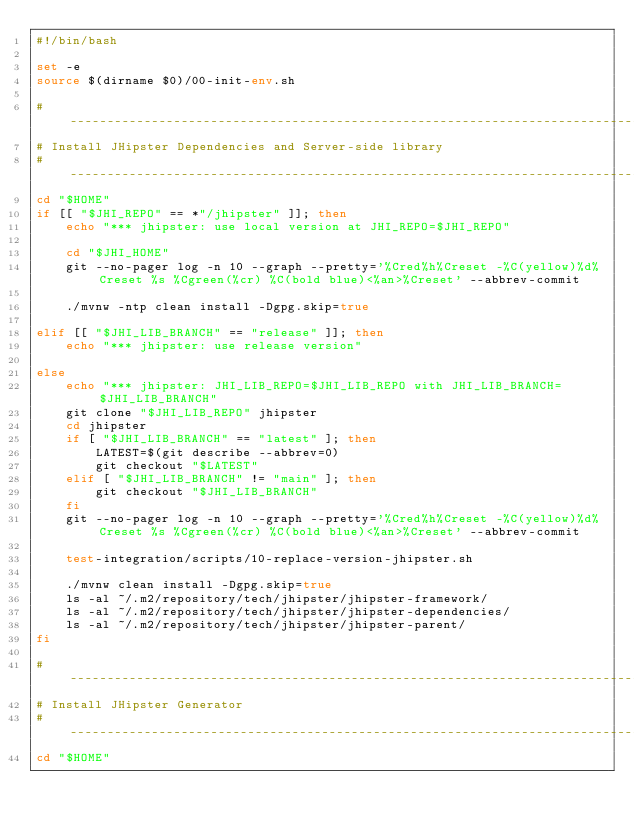Convert code to text. <code><loc_0><loc_0><loc_500><loc_500><_Bash_>#!/bin/bash

set -e
source $(dirname $0)/00-init-env.sh

#-------------------------------------------------------------------------------
# Install JHipster Dependencies and Server-side library
#-------------------------------------------------------------------------------
cd "$HOME"
if [[ "$JHI_REPO" == *"/jhipster" ]]; then
    echo "*** jhipster: use local version at JHI_REPO=$JHI_REPO"

    cd "$JHI_HOME"
    git --no-pager log -n 10 --graph --pretty='%Cred%h%Creset -%C(yellow)%d%Creset %s %Cgreen(%cr) %C(bold blue)<%an>%Creset' --abbrev-commit

    ./mvnw -ntp clean install -Dgpg.skip=true

elif [[ "$JHI_LIB_BRANCH" == "release" ]]; then
    echo "*** jhipster: use release version"

else
    echo "*** jhipster: JHI_LIB_REPO=$JHI_LIB_REPO with JHI_LIB_BRANCH=$JHI_LIB_BRANCH"
    git clone "$JHI_LIB_REPO" jhipster
    cd jhipster
    if [ "$JHI_LIB_BRANCH" == "latest" ]; then
        LATEST=$(git describe --abbrev=0)
        git checkout "$LATEST"
    elif [ "$JHI_LIB_BRANCH" != "main" ]; then
        git checkout "$JHI_LIB_BRANCH"
    fi
    git --no-pager log -n 10 --graph --pretty='%Cred%h%Creset -%C(yellow)%d%Creset %s %Cgreen(%cr) %C(bold blue)<%an>%Creset' --abbrev-commit

    test-integration/scripts/10-replace-version-jhipster.sh

    ./mvnw clean install -Dgpg.skip=true
    ls -al ~/.m2/repository/tech/jhipster/jhipster-framework/
    ls -al ~/.m2/repository/tech/jhipster/jhipster-dependencies/
    ls -al ~/.m2/repository/tech/jhipster/jhipster-parent/
fi

#-------------------------------------------------------------------------------
# Install JHipster Generator
#-------------------------------------------------------------------------------
cd "$HOME"</code> 